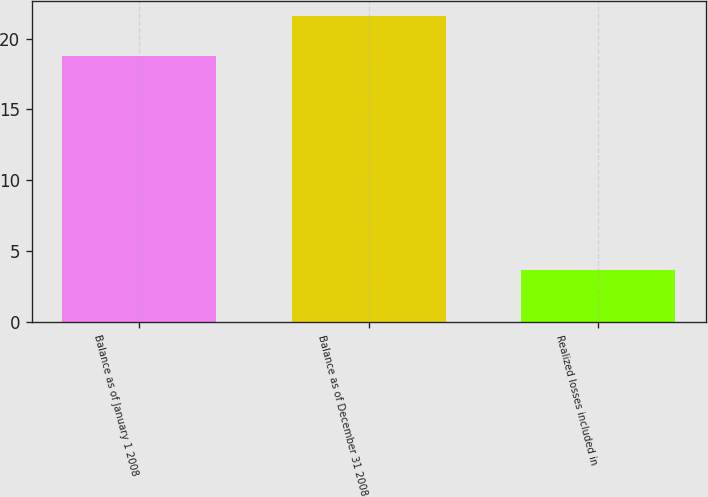Convert chart. <chart><loc_0><loc_0><loc_500><loc_500><bar_chart><fcel>Balance as of January 1 2008<fcel>Balance as of December 31 2008<fcel>Realized losses included in<nl><fcel>18.8<fcel>21.6<fcel>3.7<nl></chart> 